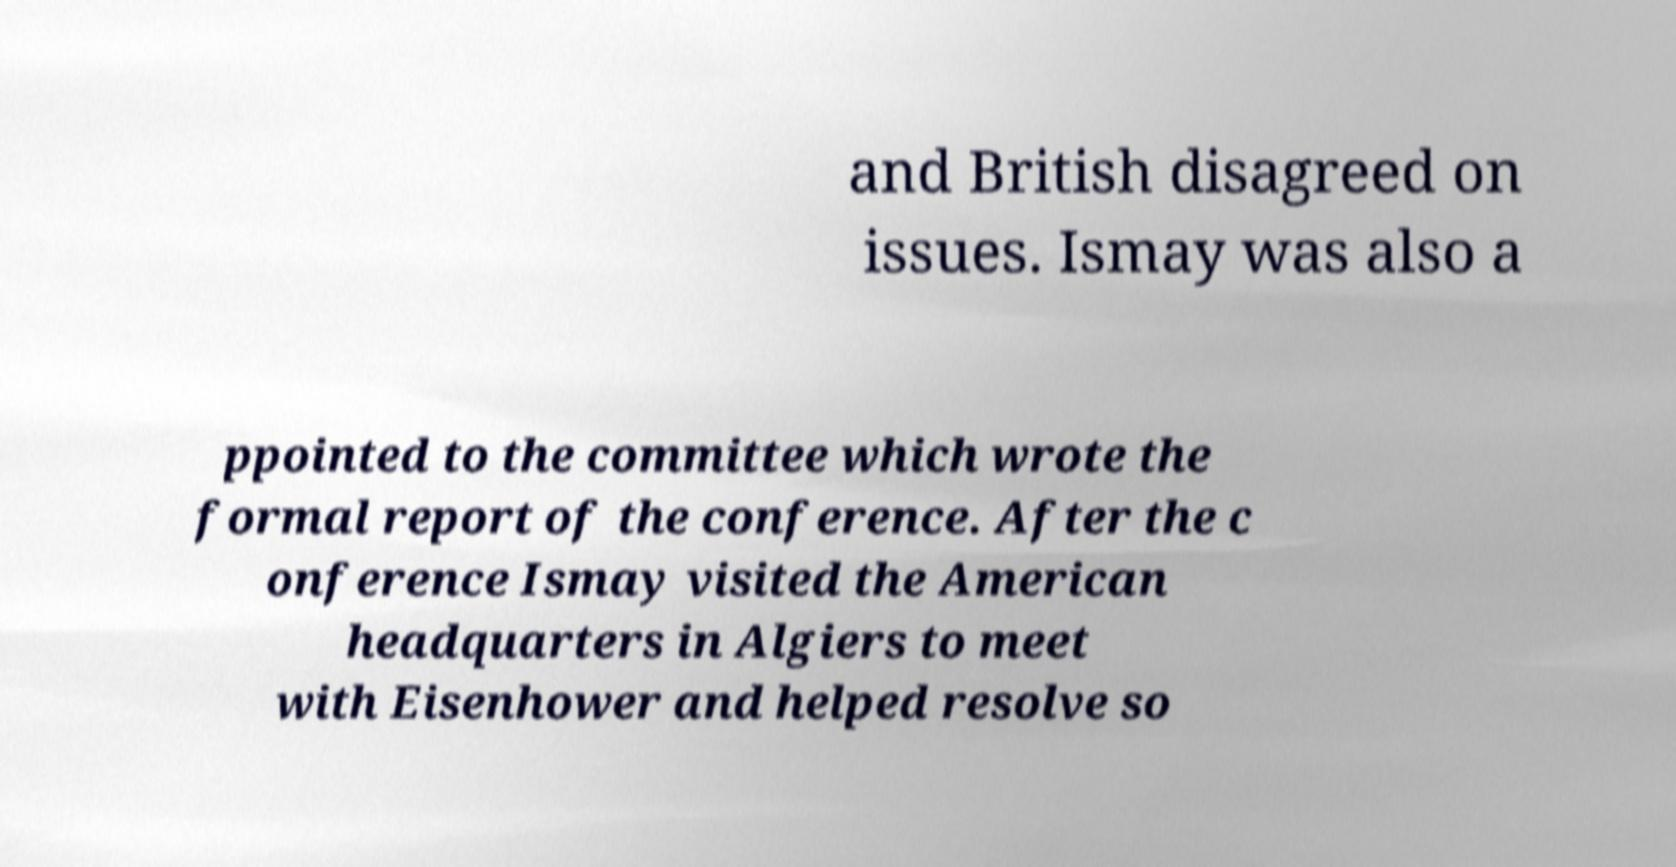Please read and relay the text visible in this image. What does it say? and British disagreed on issues. Ismay was also a ppointed to the committee which wrote the formal report of the conference. After the c onference Ismay visited the American headquarters in Algiers to meet with Eisenhower and helped resolve so 